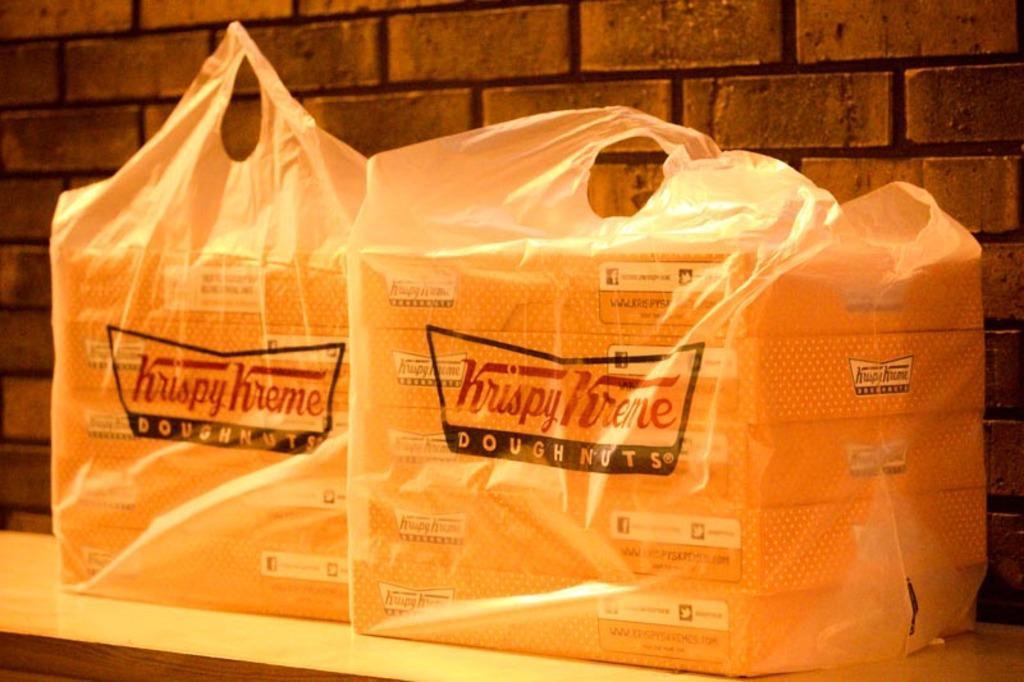Describe this image in one or two sentences. These are the two covers and this is the brick wall. 